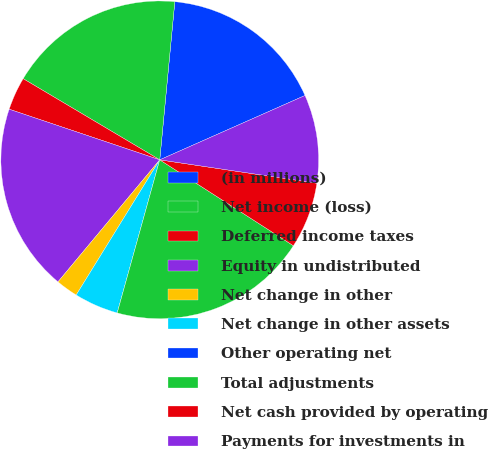Convert chart. <chart><loc_0><loc_0><loc_500><loc_500><pie_chart><fcel>(in millions)<fcel>Net income (loss)<fcel>Deferred income taxes<fcel>Equity in undistributed<fcel>Net change in other<fcel>Net change in other assets<fcel>Other operating net<fcel>Total adjustments<fcel>Net cash provided by operating<fcel>Payments for investments in<nl><fcel>16.85%<fcel>17.98%<fcel>3.37%<fcel>19.1%<fcel>2.25%<fcel>4.5%<fcel>0.0%<fcel>20.22%<fcel>6.74%<fcel>8.99%<nl></chart> 